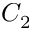<formula> <loc_0><loc_0><loc_500><loc_500>C _ { 2 }</formula> 